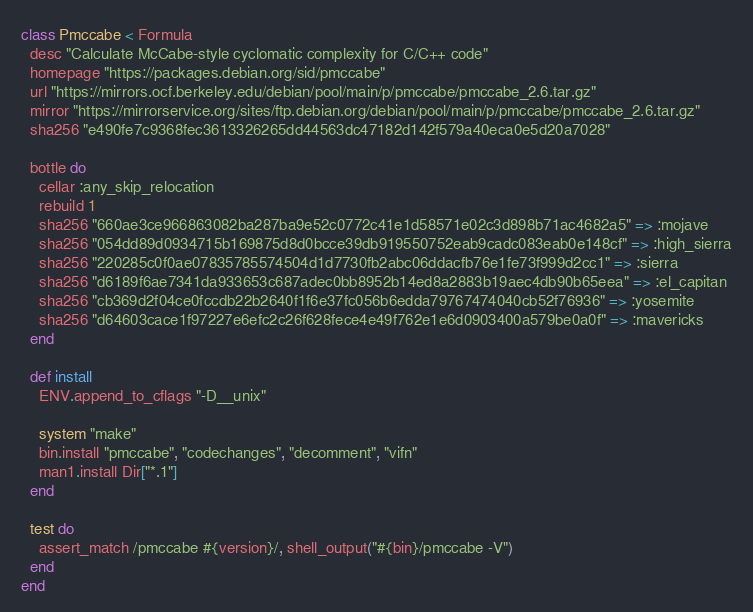<code> <loc_0><loc_0><loc_500><loc_500><_Ruby_>class Pmccabe < Formula
  desc "Calculate McCabe-style cyclomatic complexity for C/C++ code"
  homepage "https://packages.debian.org/sid/pmccabe"
  url "https://mirrors.ocf.berkeley.edu/debian/pool/main/p/pmccabe/pmccabe_2.6.tar.gz"
  mirror "https://mirrorservice.org/sites/ftp.debian.org/debian/pool/main/p/pmccabe/pmccabe_2.6.tar.gz"
  sha256 "e490fe7c9368fec3613326265dd44563dc47182d142f579a40eca0e5d20a7028"

  bottle do
    cellar :any_skip_relocation
    rebuild 1
    sha256 "660ae3ce966863082ba287ba9e52c0772c41e1d58571e02c3d898b71ac4682a5" => :mojave
    sha256 "054dd89d0934715b169875d8d0bcce39db919550752eab9cadc083eab0e148cf" => :high_sierra
    sha256 "220285c0f0ae07835785574504d1d7730fb2abc06ddacfb76e1fe73f999d2cc1" => :sierra
    sha256 "d6189f6ae7341da933653c687adec0bb8952b14ed8a2883b19aec4db90b65eea" => :el_capitan
    sha256 "cb369d2f04ce0fccdb22b2640f1f6e37fc056b6edda79767474040cb52f76936" => :yosemite
    sha256 "d64603cace1f97227e6efc2c26f628fece4e49f762e1e6d0903400a579be0a0f" => :mavericks
  end

  def install
    ENV.append_to_cflags "-D__unix"

    system "make"
    bin.install "pmccabe", "codechanges", "decomment", "vifn"
    man1.install Dir["*.1"]
  end

  test do
    assert_match /pmccabe #{version}/, shell_output("#{bin}/pmccabe -V")
  end
end
</code> 